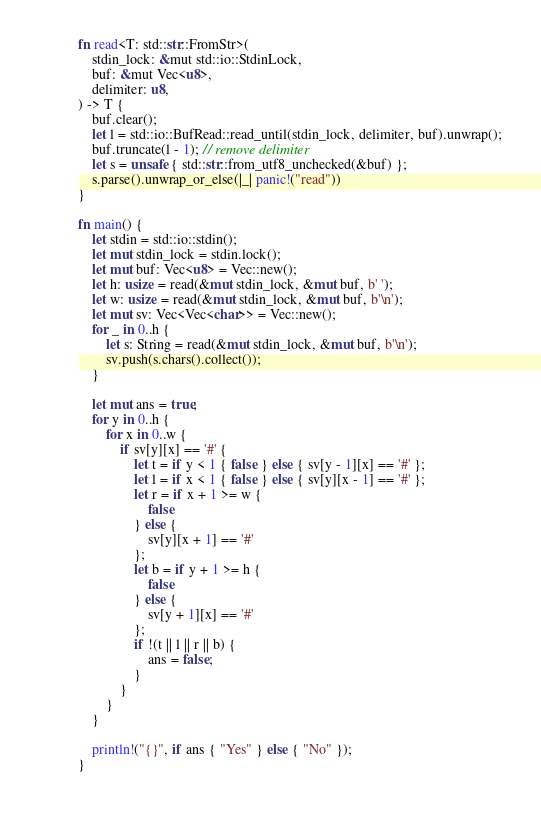Convert code to text. <code><loc_0><loc_0><loc_500><loc_500><_Rust_>fn read<T: std::str::FromStr>(
    stdin_lock: &mut std::io::StdinLock,
    buf: &mut Vec<u8>,
    delimiter: u8,
) -> T {
    buf.clear();
    let l = std::io::BufRead::read_until(stdin_lock, delimiter, buf).unwrap();
    buf.truncate(l - 1); // remove delimiter
    let s = unsafe { std::str::from_utf8_unchecked(&buf) };
    s.parse().unwrap_or_else(|_| panic!("read"))
}

fn main() {
    let stdin = std::io::stdin();
    let mut stdin_lock = stdin.lock();
    let mut buf: Vec<u8> = Vec::new();
    let h: usize = read(&mut stdin_lock, &mut buf, b' ');
    let w: usize = read(&mut stdin_lock, &mut buf, b'\n');
    let mut sv: Vec<Vec<char>> = Vec::new();
    for _ in 0..h {
        let s: String = read(&mut stdin_lock, &mut buf, b'\n');
        sv.push(s.chars().collect());
    }

    let mut ans = true;
    for y in 0..h {
        for x in 0..w {
            if sv[y][x] == '#' {
                let t = if y < 1 { false } else { sv[y - 1][x] == '#' };
                let l = if x < 1 { false } else { sv[y][x - 1] == '#' };
                let r = if x + 1 >= w {
                    false
                } else {
                    sv[y][x + 1] == '#'
                };
                let b = if y + 1 >= h {
                    false
                } else {
                    sv[y + 1][x] == '#'
                };
                if !(t || l || r || b) {
                    ans = false;
                }
            }
        }
    }

    println!("{}", if ans { "Yes" } else { "No" });
}
</code> 